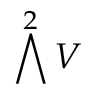<formula> <loc_0><loc_0><loc_500><loc_500>\bigwedge ^ { 2 } V</formula> 